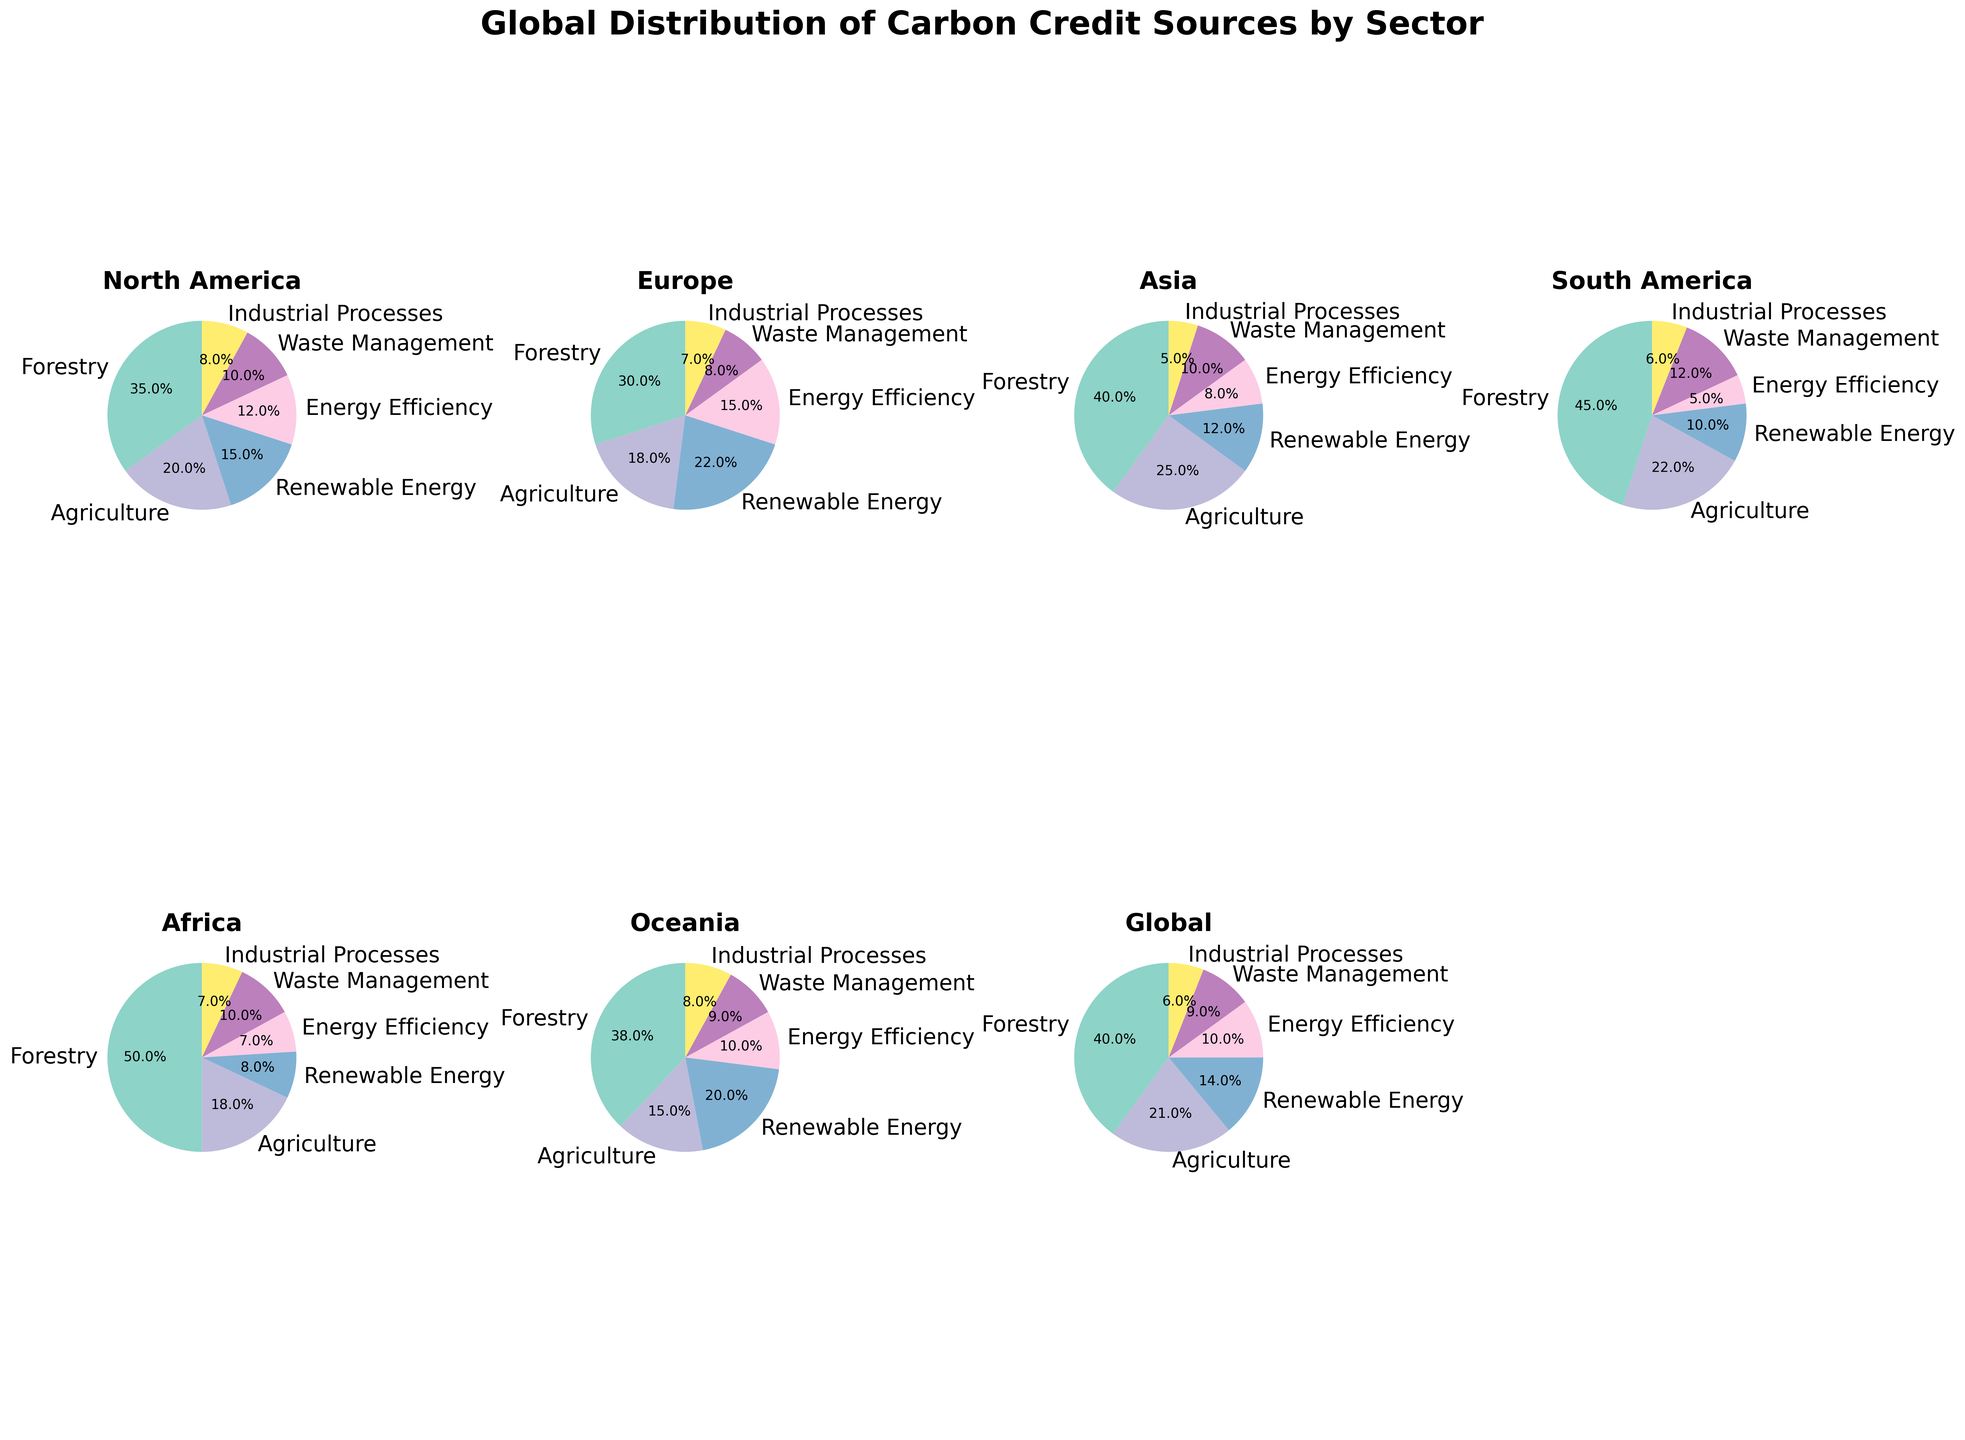What sector contributes the most to carbon credits in Africa? The pie chart for Africa shows the largest sector with the highest percentage, which is Forestry.
Answer: Forestry How does the contribution of Renewable Energy in Europe compare to that in North America? From the pie charts, the percentage contribution of Renewable Energy in Europe is 22%, whereas in North America it is 15%. Hence, Europe's contribution is higher.
Answer: Europe has a higher contribution Which sector has the least contribution in Asia and what is its value? Looking at the pie chart for Asia, the least contributing sector is Industrial Processes with 5%.
Answer: Industrial Processes, 5% What is the combined percentage contribution of Agriculture and Waste Management in South America? From the South American pie chart, Agriculture contributes 22% and Waste Management contributes 12%. The combined percentage is 22 + 12 = 34%.
Answer: 34% Is the contribution of Energy Efficiency in Oceania higher or lower than that in North America? In Oceania, Energy Efficiency contributes 10%, whereas in North America it contributes 12%. Therefore, Oceania's contribution is lower.
Answer: Lower What are the contributions of Agriculture and Forestry sectors in Global data? The Global data pie chart shows Agriculture contributing 21% and Forestry contributing 40%.
Answer: Agriculture: 21%, Forestry: 40% Which region has the highest contribution of Forestry, and what is the value? By examining the pie charts of all regions, Africa has the highest Forestry contribution at 50%.
Answer: Africa, 50% Compare the contribution of Waste Management in Asia with that in South America. In Asia, Waste Management contributes 10%, while in South America, it contributes 12%. Thus, South America's contribution is higher.
Answer: South America has a higher contribution What is the difference in contribution between Industrial Processes in North America and Europe? The pie chart shows North America at 8% for Industrial Processes and Europe at 7%. The difference is 8 - 7 = 1%.
Answer: 1% 